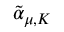<formula> <loc_0><loc_0><loc_500><loc_500>{ \tilde { \alpha } } _ { \mu , K }</formula> 